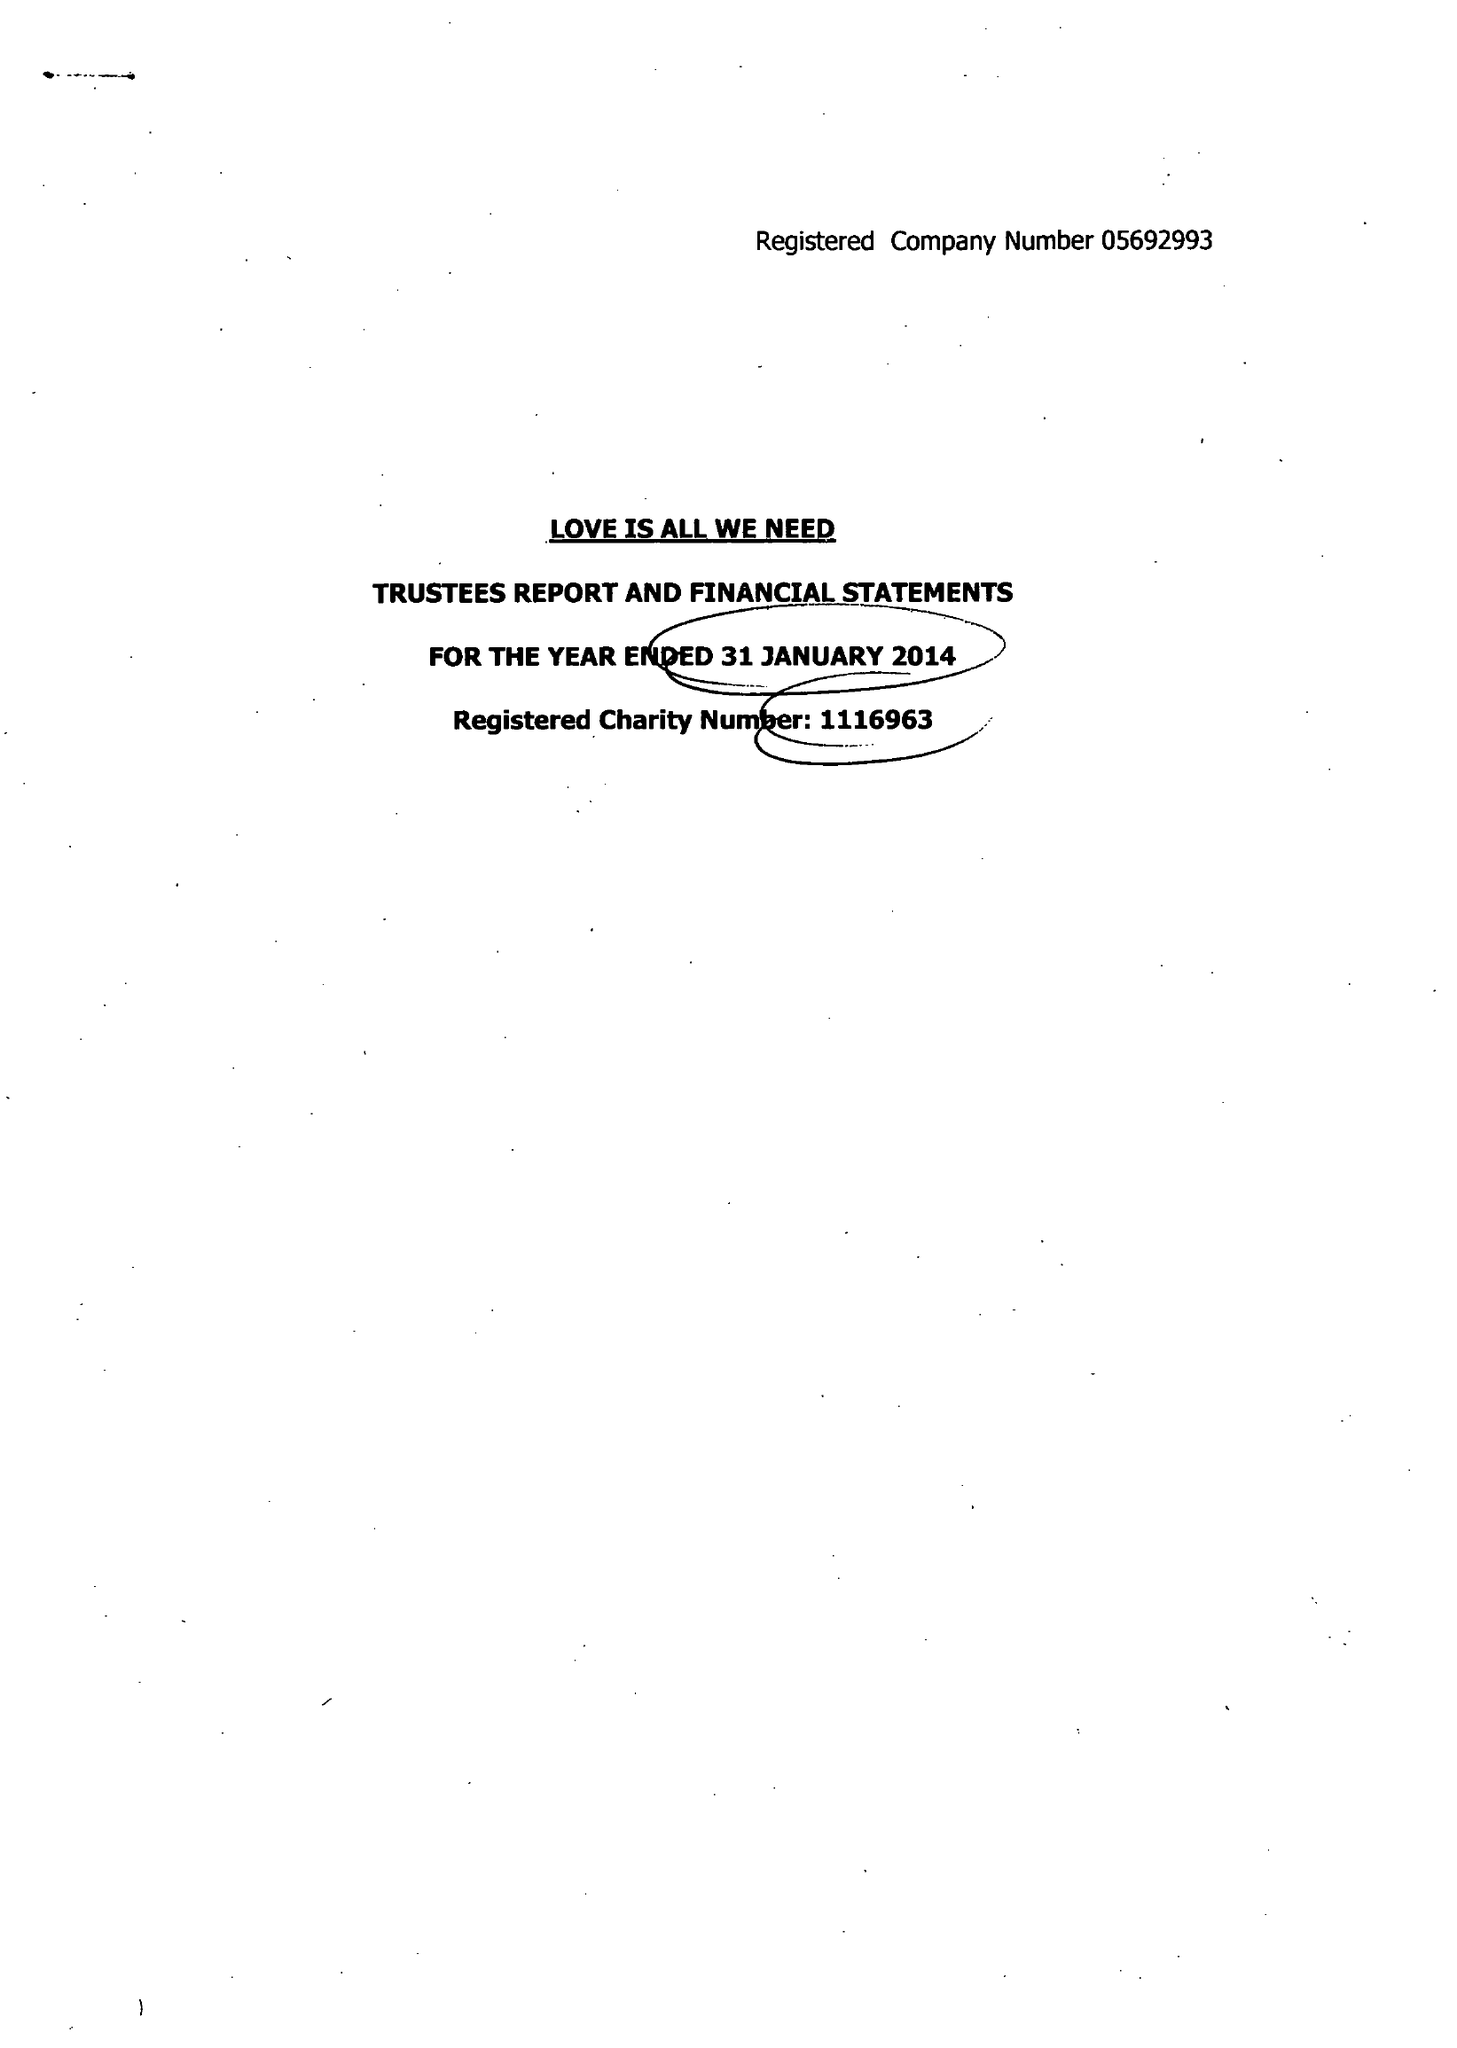What is the value for the address__postcode?
Answer the question using a single word or phrase. BN3 4FE 